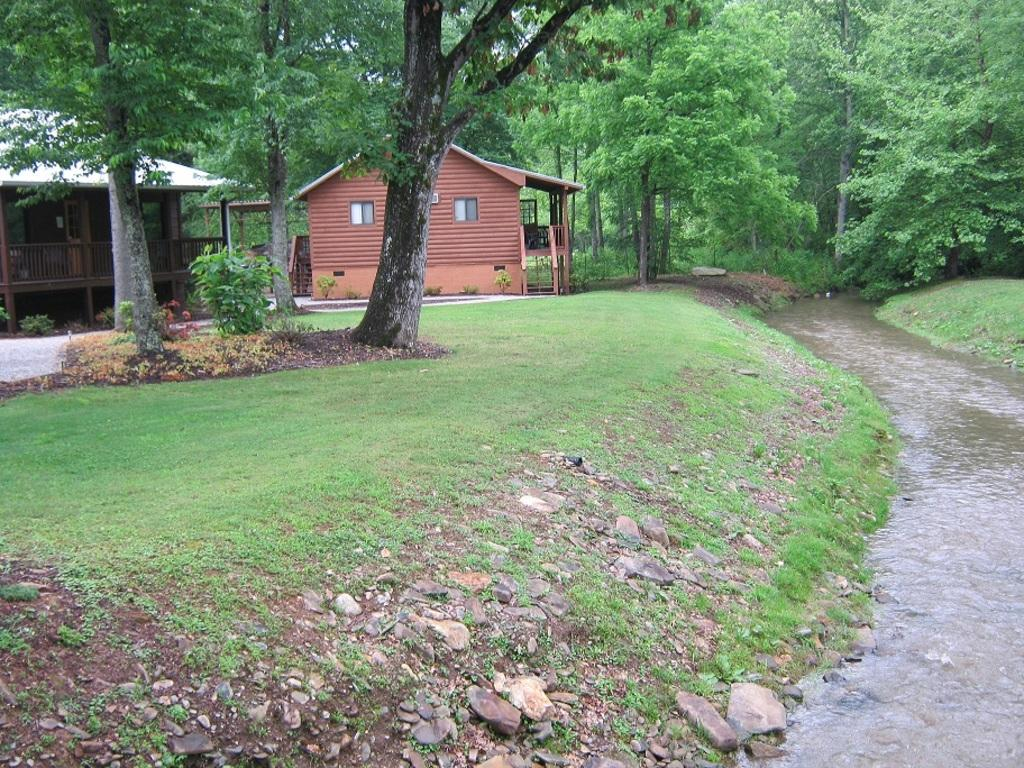What type of view is shown in the image? The image shows an outside view. What can be seen in the image besides the houses? There are trees beside the houses in the image. What body of water is present in the image? There is a canal in the bottom right of the image. What is the taste of the canal water in the image? There is no information about the taste of the canal water in the image, and it is not possible to determine the taste from the image alone. 